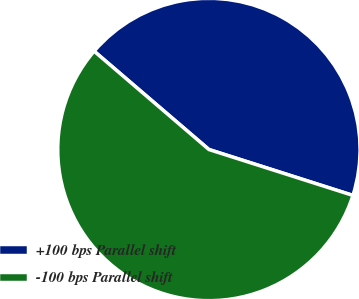Convert chart to OTSL. <chart><loc_0><loc_0><loc_500><loc_500><pie_chart><fcel>+100 bps Parallel shift<fcel>-100 bps Parallel shift<nl><fcel>43.64%<fcel>56.36%<nl></chart> 